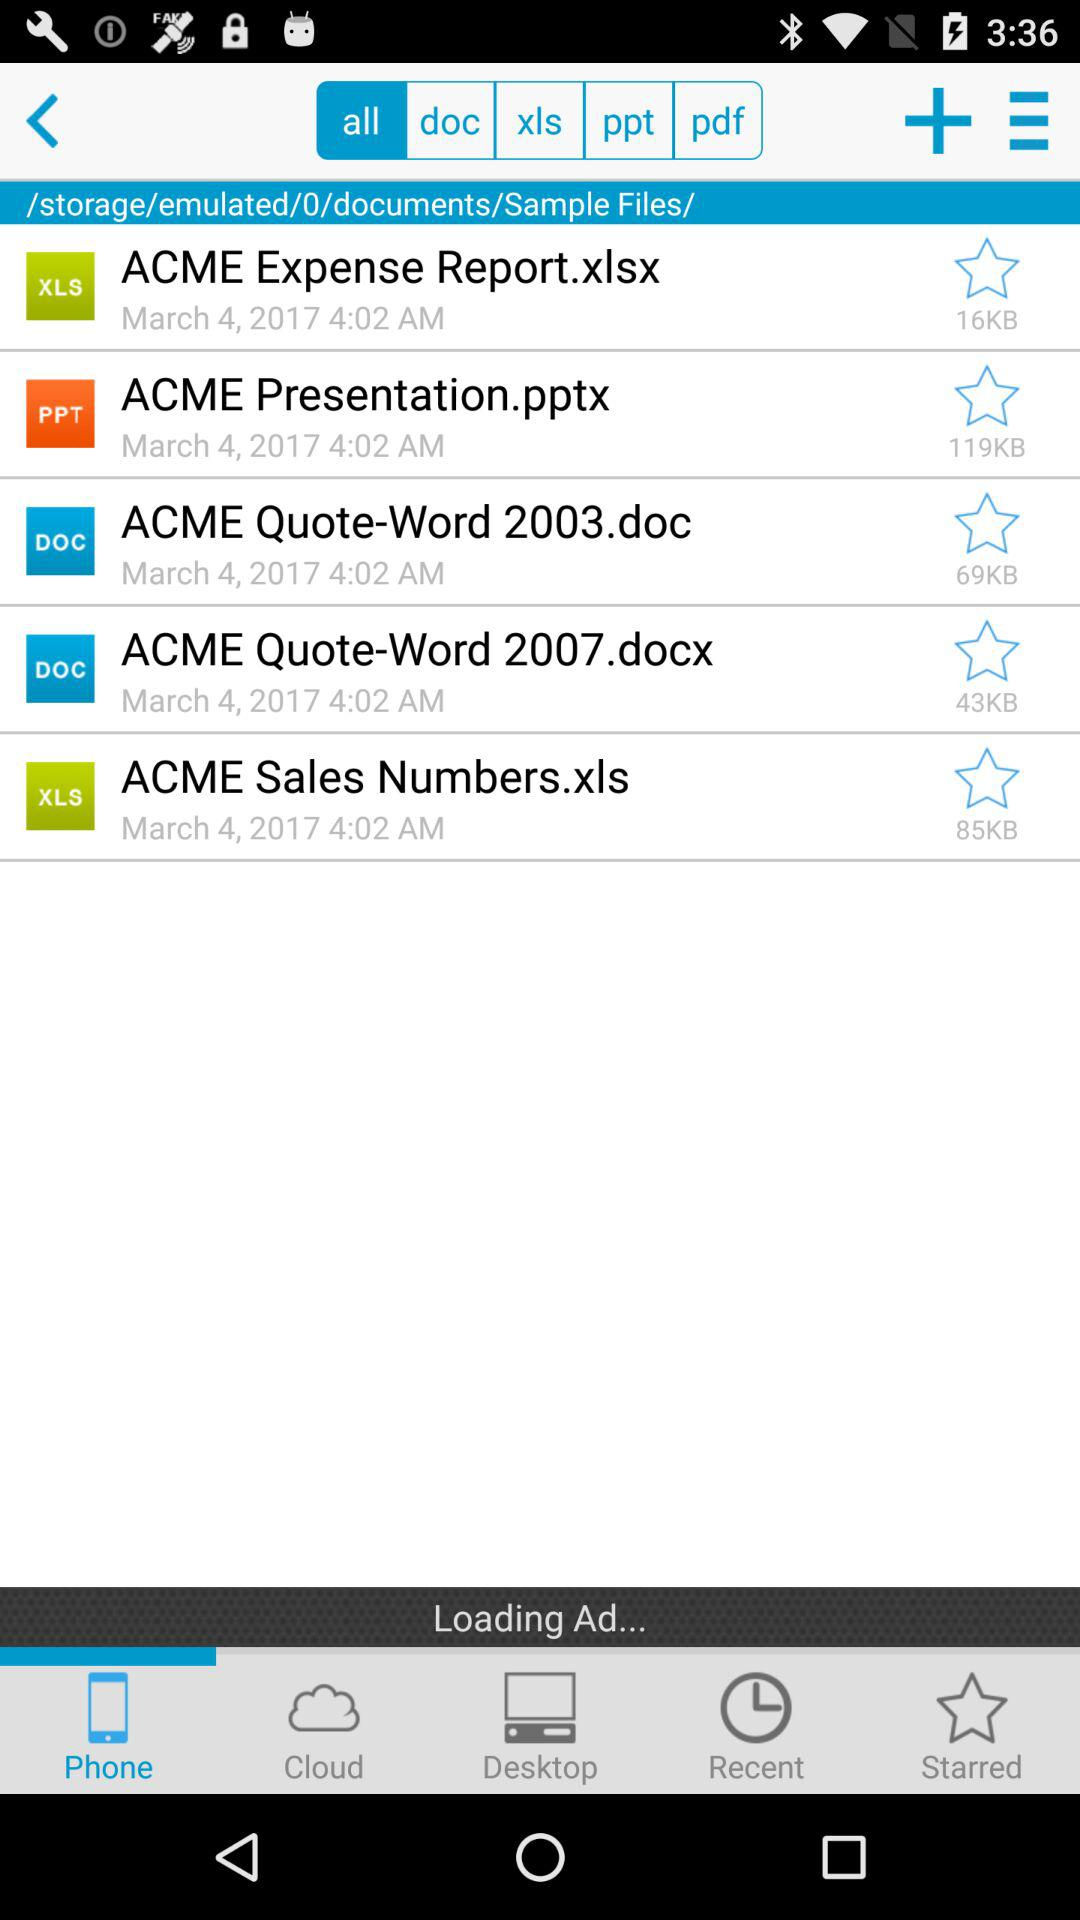What date is displayed on the screen? The date is March 4, 2017. 